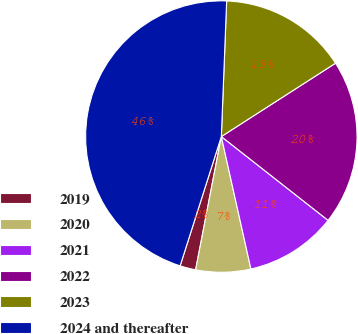<chart> <loc_0><loc_0><loc_500><loc_500><pie_chart><fcel>2019<fcel>2020<fcel>2021<fcel>2022<fcel>2023<fcel>2024 and thereafter<nl><fcel>1.88%<fcel>6.53%<fcel>10.91%<fcel>19.68%<fcel>15.29%<fcel>45.71%<nl></chart> 